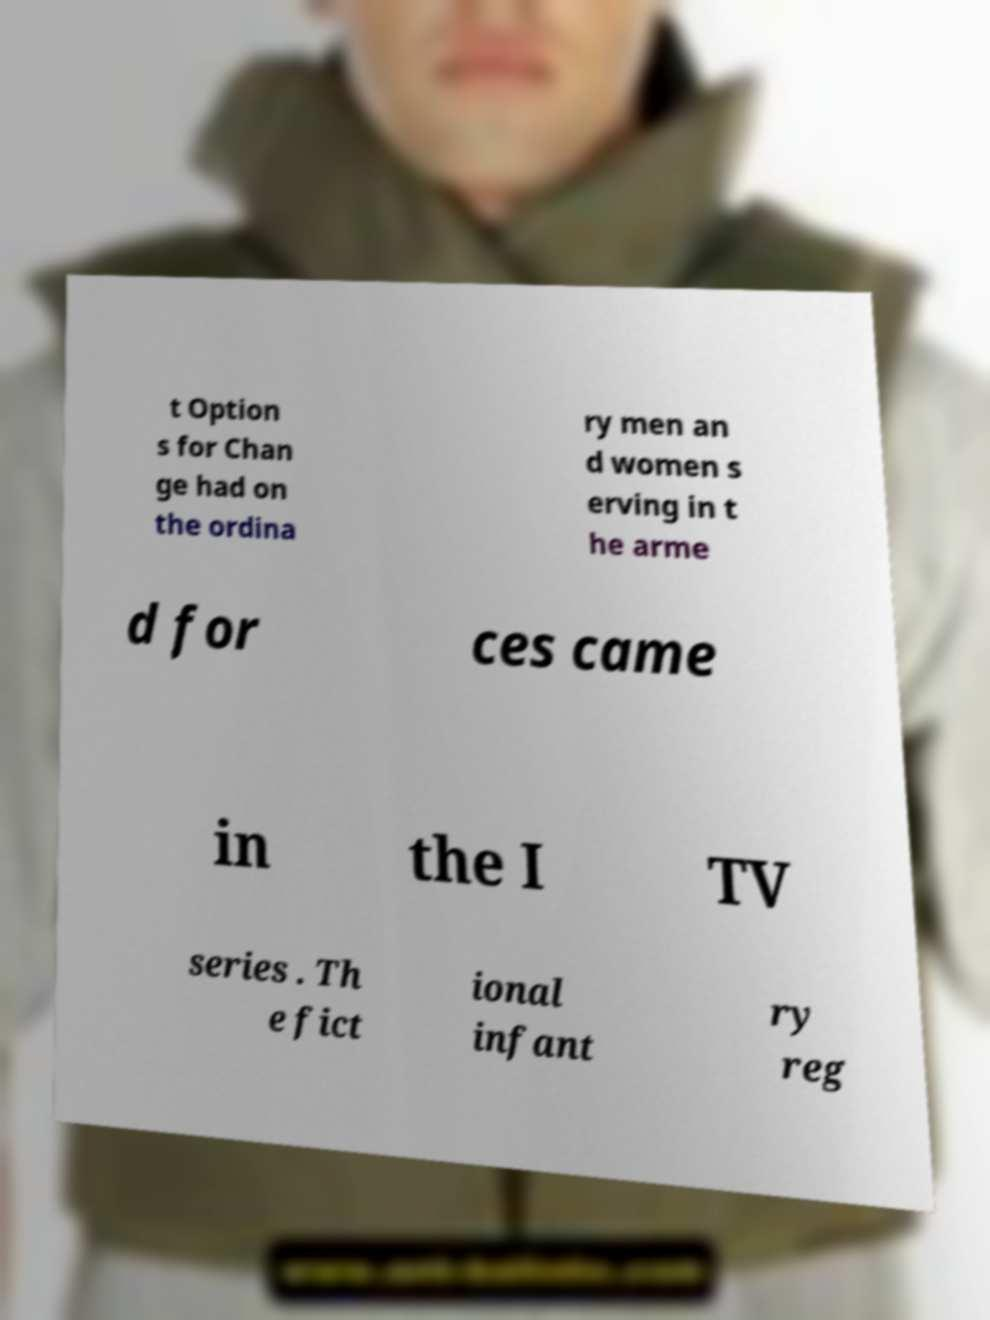Could you assist in decoding the text presented in this image and type it out clearly? t Option s for Chan ge had on the ordina ry men an d women s erving in t he arme d for ces came in the I TV series . Th e fict ional infant ry reg 